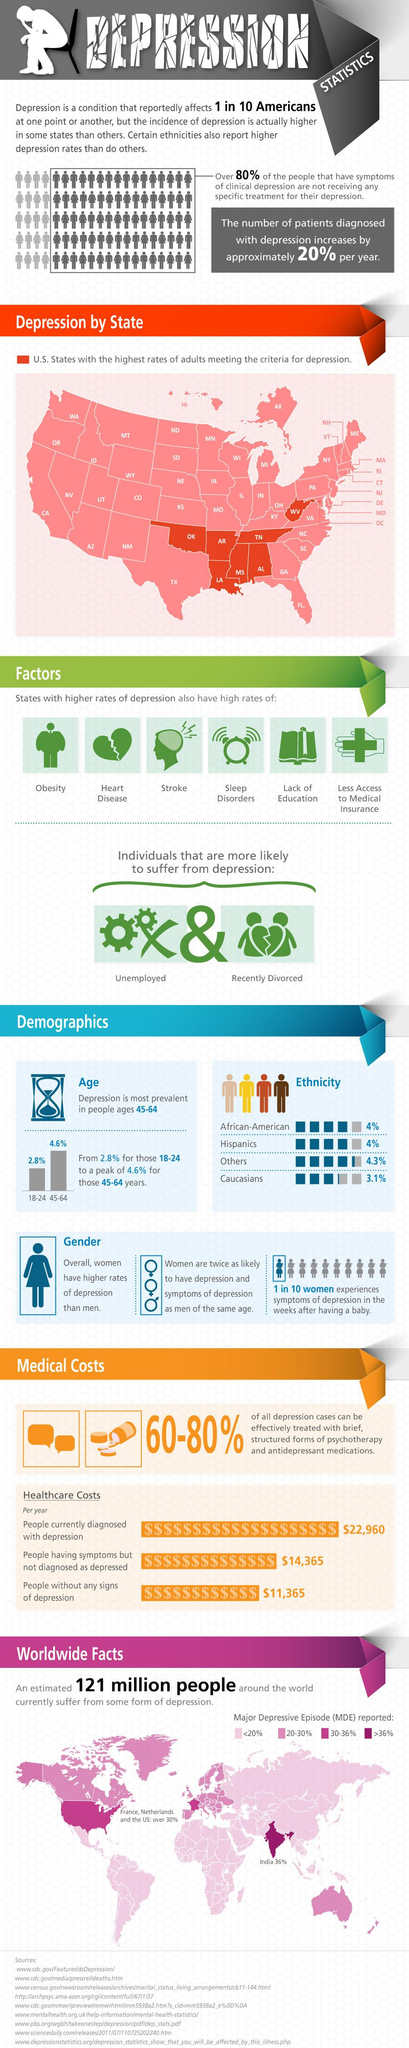List a handful of essential elements in this visual. Depression is more prevalent in the age group of 45-64. Depression is most likely to affect certain classes of individuals, such as the unemployed and those who have recently gone through a divorce. According to recent data, it is estimated that approximately 20% of depression patients in America experience a worsening of their condition on an annual basis. 